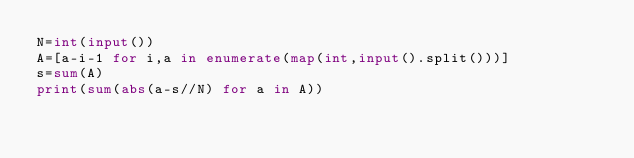Convert code to text. <code><loc_0><loc_0><loc_500><loc_500><_Python_>N=int(input())
A=[a-i-1 for i,a in enumerate(map(int,input().split()))]
s=sum(A)
print(sum(abs(a-s//N) for a in A))</code> 